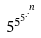Convert formula to latex. <formula><loc_0><loc_0><loc_500><loc_500>5 ^ { 5 ^ { 5 ^ { . ^ { . ^ { n } } } } }</formula> 